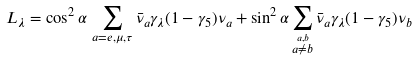Convert formula to latex. <formula><loc_0><loc_0><loc_500><loc_500>L _ { \lambda } = \cos ^ { 2 } \alpha \, \sum _ { a = e , \mu , \tau } \bar { \nu } _ { a } \gamma _ { \lambda } ( 1 - \gamma _ { 5 } ) \nu _ { a } + \sin ^ { 2 } \alpha \sum _ { \stackrel { a , b } { a \not = b } } \bar { \nu } _ { a } \gamma _ { \lambda } ( 1 - \gamma _ { 5 } ) \nu _ { b }</formula> 